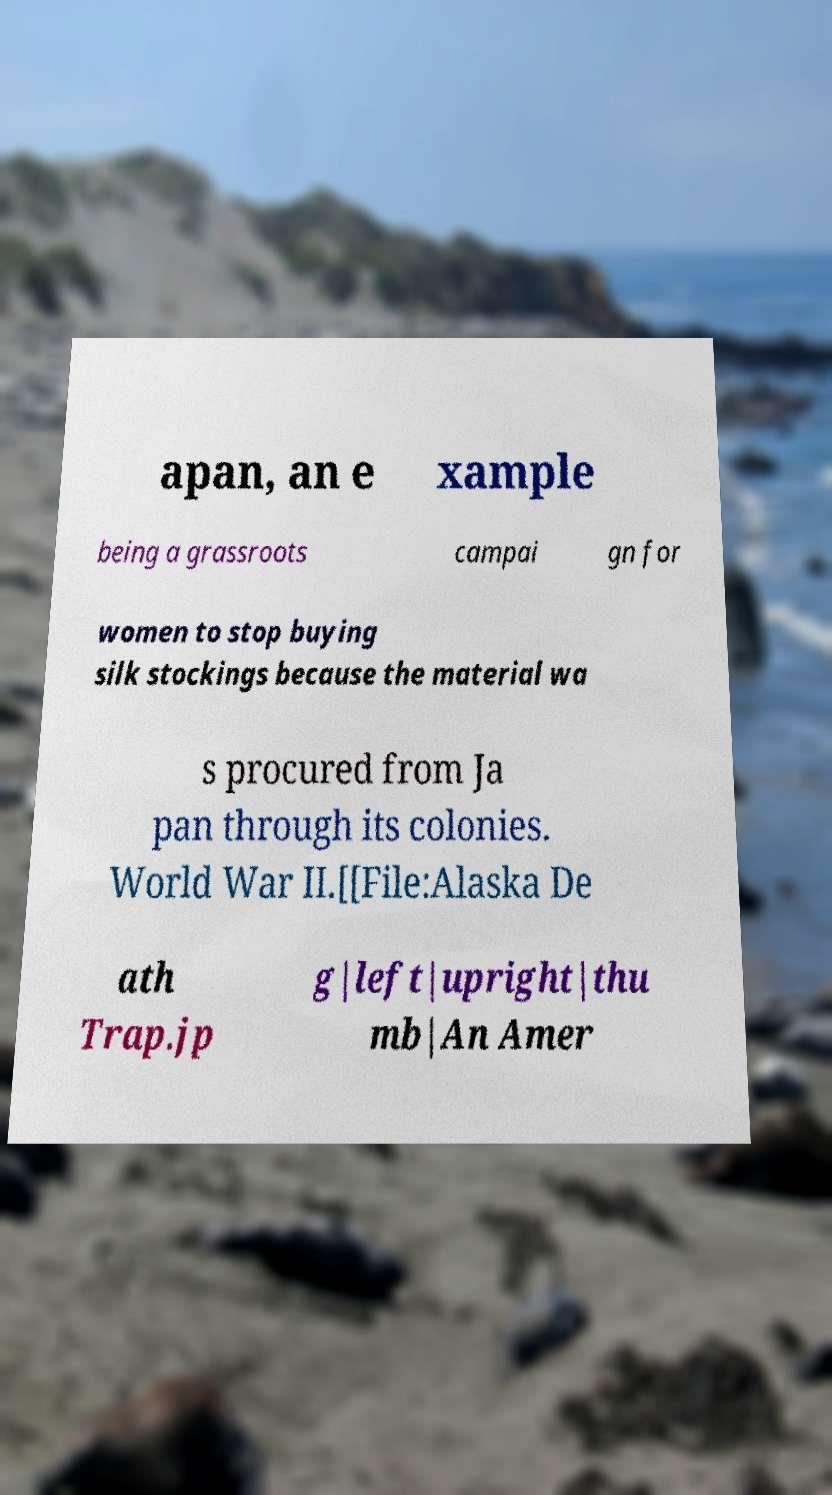Please identify and transcribe the text found in this image. apan, an e xample being a grassroots campai gn for women to stop buying silk stockings because the material wa s procured from Ja pan through its colonies. World War II.[[File:Alaska De ath Trap.jp g|left|upright|thu mb|An Amer 